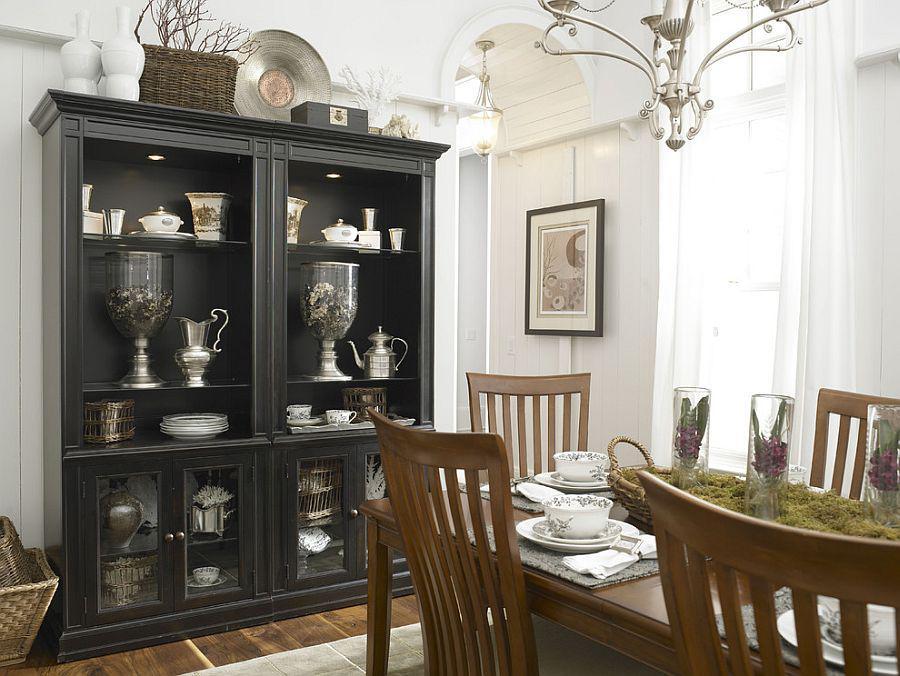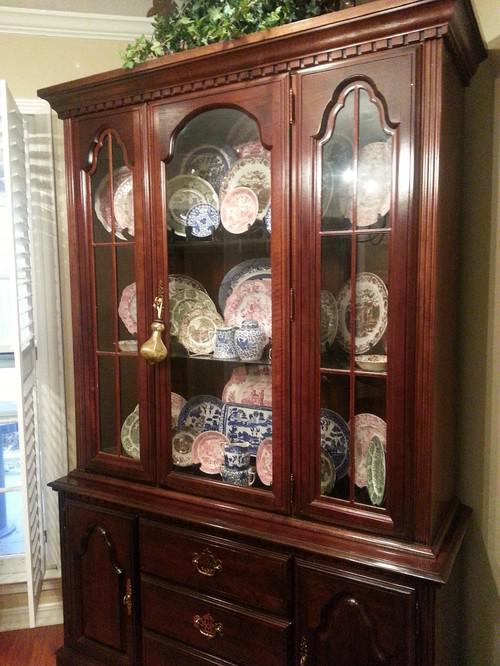The first image is the image on the left, the second image is the image on the right. Assess this claim about the two images: "There is at least one hutch that is painted dark gray.". Correct or not? Answer yes or no. Yes. The first image is the image on the left, the second image is the image on the right. Evaluate the accuracy of this statement regarding the images: "The cabinet in the image on the left has an arch over the front center.". Is it true? Answer yes or no. No. 